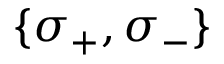<formula> <loc_0><loc_0><loc_500><loc_500>\{ \sigma _ { + } , \sigma _ { - } \}</formula> 